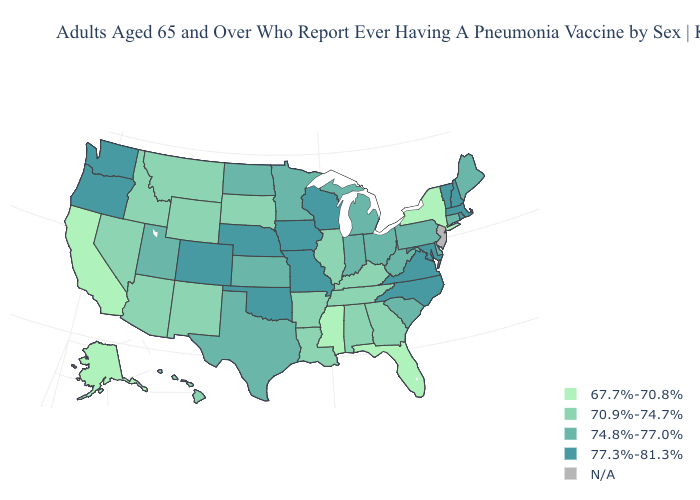Is the legend a continuous bar?
Answer briefly. No. Which states have the lowest value in the MidWest?
Quick response, please. Illinois, South Dakota. Name the states that have a value in the range N/A?
Keep it brief. New Jersey. Does Mississippi have the lowest value in the South?
Keep it brief. Yes. Name the states that have a value in the range 74.8%-77.0%?
Give a very brief answer. Connecticut, Delaware, Indiana, Kansas, Maine, Michigan, Minnesota, North Dakota, Ohio, Pennsylvania, South Carolina, Texas, Utah, West Virginia. Name the states that have a value in the range 67.7%-70.8%?
Quick response, please. Alaska, California, Florida, Mississippi, New York. Name the states that have a value in the range 67.7%-70.8%?
Concise answer only. Alaska, California, Florida, Mississippi, New York. What is the value of Louisiana?
Short answer required. 70.9%-74.7%. Among the states that border Ohio , does Pennsylvania have the lowest value?
Be succinct. No. Which states hav the highest value in the MidWest?
Answer briefly. Iowa, Missouri, Nebraska, Wisconsin. Name the states that have a value in the range 70.9%-74.7%?
Quick response, please. Alabama, Arizona, Arkansas, Georgia, Hawaii, Idaho, Illinois, Kentucky, Louisiana, Montana, Nevada, New Mexico, South Dakota, Tennessee, Wyoming. Name the states that have a value in the range 74.8%-77.0%?
Be succinct. Connecticut, Delaware, Indiana, Kansas, Maine, Michigan, Minnesota, North Dakota, Ohio, Pennsylvania, South Carolina, Texas, Utah, West Virginia. Name the states that have a value in the range 70.9%-74.7%?
Short answer required. Alabama, Arizona, Arkansas, Georgia, Hawaii, Idaho, Illinois, Kentucky, Louisiana, Montana, Nevada, New Mexico, South Dakota, Tennessee, Wyoming. 